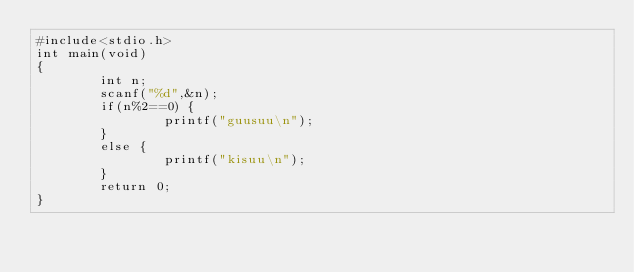Convert code to text. <code><loc_0><loc_0><loc_500><loc_500><_C_>#include<stdio.h>
int main(void)
{
		int n;
		scanf("%d",&n);
		if(n%2==0) {
				printf("guusuu\n");
		}
		else {
				printf("kisuu\n");
		}
		return 0;
}</code> 